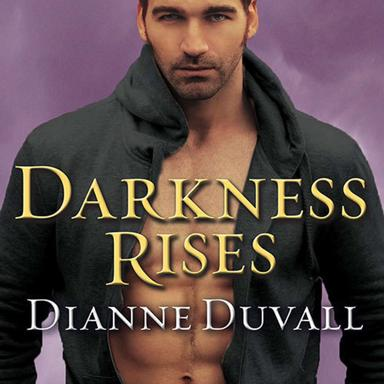Why might the color purple be significant in the cover design of 'Darkness Rises'? The color purple on the cover of 'Darkness Rises' is often associated with mystery, magic, and royalty. In the context of a paranormal romance, these associations enrich the atmospheric tone of the book, suggesting a world of enigmatic and supernatural elements that awaits the reader. 